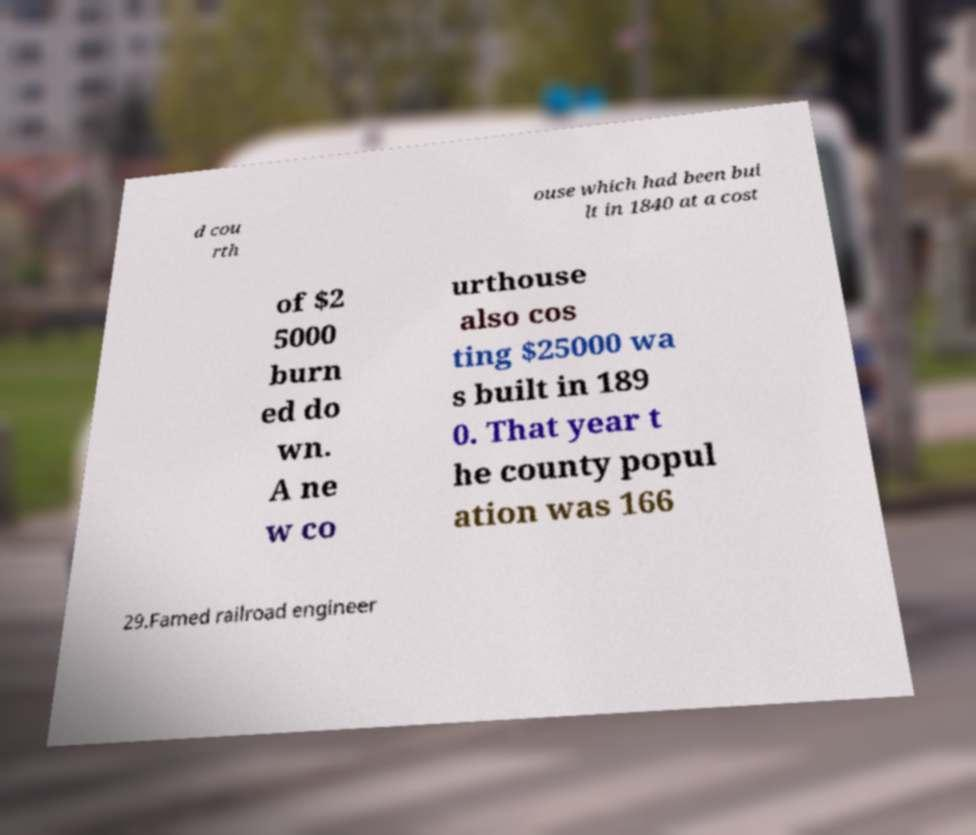For documentation purposes, I need the text within this image transcribed. Could you provide that? d cou rth ouse which had been bui lt in 1840 at a cost of $2 5000 burn ed do wn. A ne w co urthouse also cos ting $25000 wa s built in 189 0. That year t he county popul ation was 166 29.Famed railroad engineer 